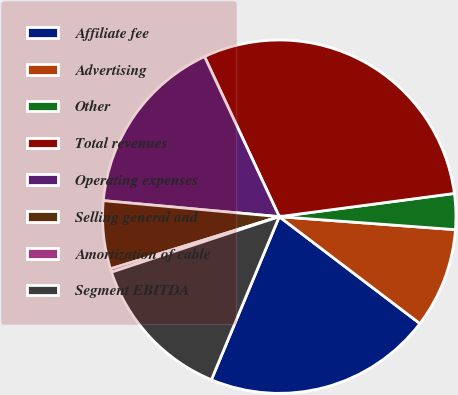<chart> <loc_0><loc_0><loc_500><loc_500><pie_chart><fcel>Affiliate fee<fcel>Advertising<fcel>Other<fcel>Total revenues<fcel>Operating expenses<fcel>Selling general and<fcel>Amortization of cable<fcel>Segment EBITDA<nl><fcel>20.93%<fcel>9.17%<fcel>3.27%<fcel>29.85%<fcel>16.6%<fcel>6.22%<fcel>0.31%<fcel>13.64%<nl></chart> 